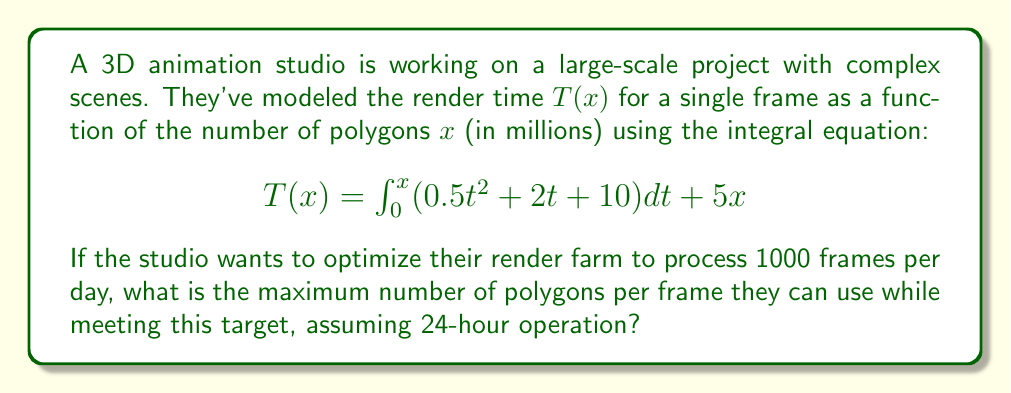Show me your answer to this math problem. Let's approach this step-by-step:

1) First, we need to solve the integral equation for $T(x)$:

   $$T(x) = \int_0^x (0.5t^2 + 2t + 10) dt + 5x$$

2) Solving the integral:

   $$T(x) = [\frac{1}{6}t^3 + t^2 + 10t]_0^x + 5x$$
   $$T(x) = \frac{1}{6}x^3 + x^2 + 10x + 5x$$
   $$T(x) = \frac{1}{6}x^3 + x^2 + 15x$$

3) Now, we need to find the total render time for 1000 frames:

   $$1000 \cdot T(x) = 1000(\frac{1}{6}x^3 + x^2 + 15x)$$

4) The studio operates 24 hours a day, so we can set up an equation:

   $$1000(\frac{1}{6}x^3 + x^2 + 15x) = 24 \cdot 60 \cdot 60 = 86400$$

5) Simplifying:

   $$\frac{1000}{6}x^3 + 1000x^2 + 15000x = 86400$$
   $$\frac{500}{3}x^3 + 1000x^2 + 15000x - 86400 = 0$$

6) This is a cubic equation. We can solve it numerically using methods like Newton-Raphson or by using a graphing calculator.

7) Solving numerically, we find that $x \approx 2.1454$.

Therefore, the maximum number of polygons per frame is approximately 2.1454 million.
Answer: 2.1454 million polygons 